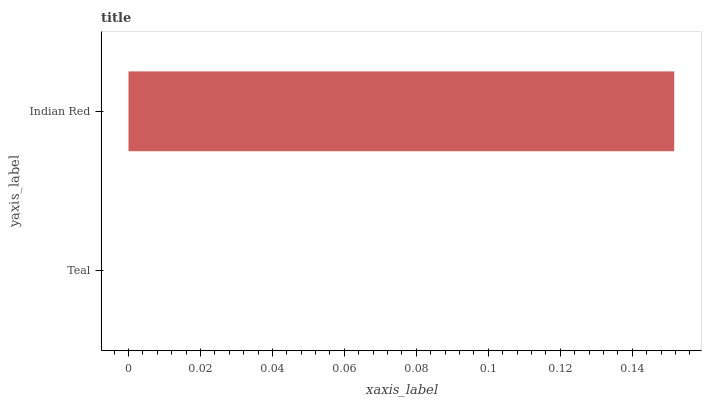Is Teal the minimum?
Answer yes or no. Yes. Is Indian Red the maximum?
Answer yes or no. Yes. Is Indian Red the minimum?
Answer yes or no. No. Is Indian Red greater than Teal?
Answer yes or no. Yes. Is Teal less than Indian Red?
Answer yes or no. Yes. Is Teal greater than Indian Red?
Answer yes or no. No. Is Indian Red less than Teal?
Answer yes or no. No. Is Indian Red the high median?
Answer yes or no. Yes. Is Teal the low median?
Answer yes or no. Yes. Is Teal the high median?
Answer yes or no. No. Is Indian Red the low median?
Answer yes or no. No. 